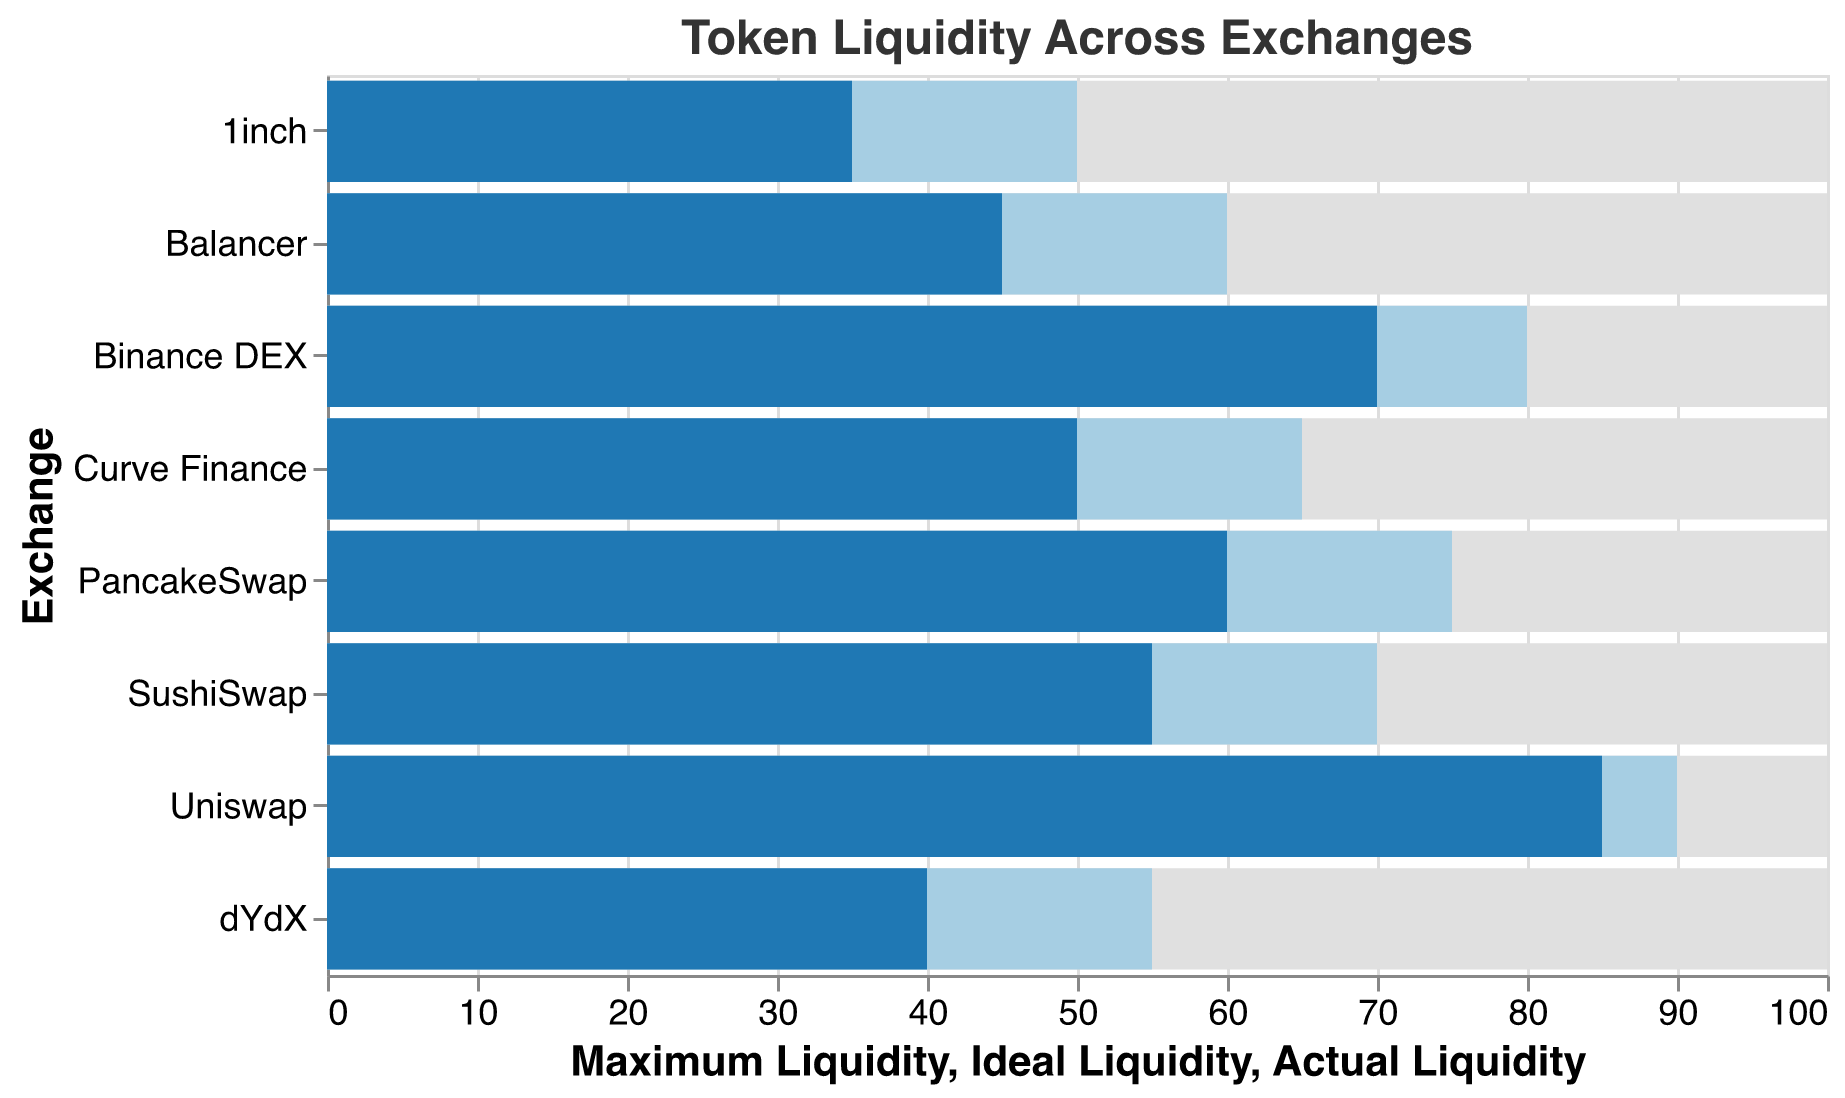What is the title of the chart? The title of the chart is located at the top-center and reads "Token Liquidity Across Exchanges".
Answer: Token Liquidity Across Exchanges Which exchange has the highest actual liquidity? The bar representing actual liquidity for Uniswap is the longest among all exchanges, indicating it has the highest actual liquidity.
Answer: Uniswap Is the actual liquidity in Binance DEX higher or lower than its ideal liquidity? The blue bar representing actual liquidity in Binance DEX is smaller in length compared to the light-blue bar representing ideal liquidity, indicating that the actual liquidity is lower than the ideal liquidity.
Answer: Lower What is the difference between the ideal and actual liquidity for Curve Finance? The ideal liquidity for Curve Finance is 65 and the actual liquidity is 50. The difference is calculated as 65 - 50 = 15.
Answer: 15 Which exchange has the smallest difference between actual and ideal liquidity? By comparing the differences for each exchange, Uniswap has the smallest difference, with the ideal liquidity at 90 and the actual at 85, resulting in a difference of 5.
Answer: Uniswap How many exchanges have their ideal liquidity at 75 or higher? By examining the length of the light-blue bars, Uniswap, Binance DEX, and PancakeSwap have ideal liquidity of 75 or higher.
Answer: 3 What is the average actual liquidity across all exchanges? The sum of actual liquidity values is 85 + 70 + 60 + 55 + 50 + 45 + 40 + 35 = 440. There are 8 exchanges; hence, the average actual liquidity is 440 / 8 = 55.
Answer: 55 Which exchange has the largest gap between its maximum and actual liquidity? Comparing the gaps (maximum - actual) for each exchange, 1inch has the largest gap with maximum liquidity of 100 and actual liquidity of 35, resulting in a gap of 65.
Answer: 1inch 